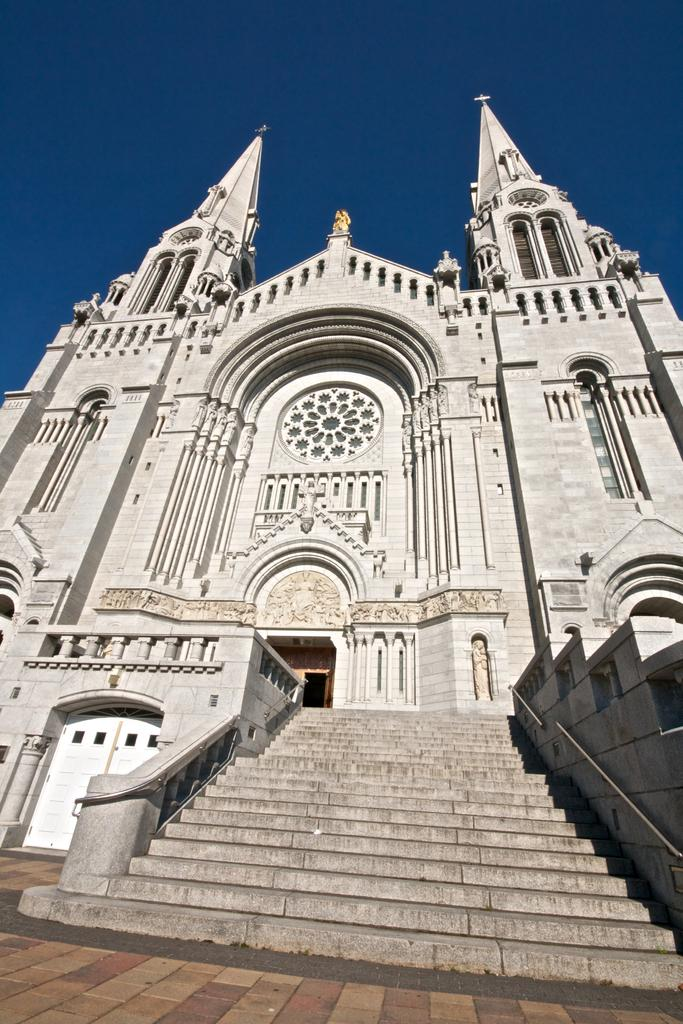What type of building is in the image? There is a church building in the image. What feature is present in front of the church building? The church building has stairs in front of it. Can you describe the entrance of the church building? There is a closed door on the church building. What type of root can be seen growing on the church building in the image? There is no root growing on the church building in the image. 